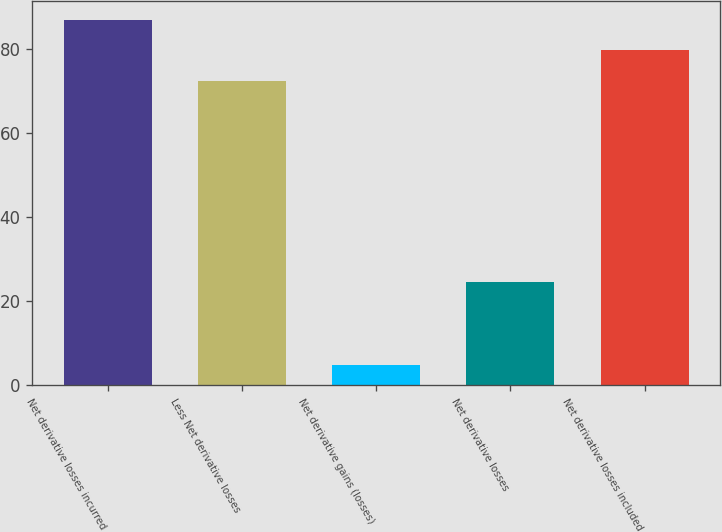Convert chart to OTSL. <chart><loc_0><loc_0><loc_500><loc_500><bar_chart><fcel>Net derivative losses incurred<fcel>Less Net derivative losses<fcel>Net derivative gains (losses)<fcel>Net derivative losses<fcel>Net derivative losses included<nl><fcel>87<fcel>72.5<fcel>4.9<fcel>24.5<fcel>79.75<nl></chart> 